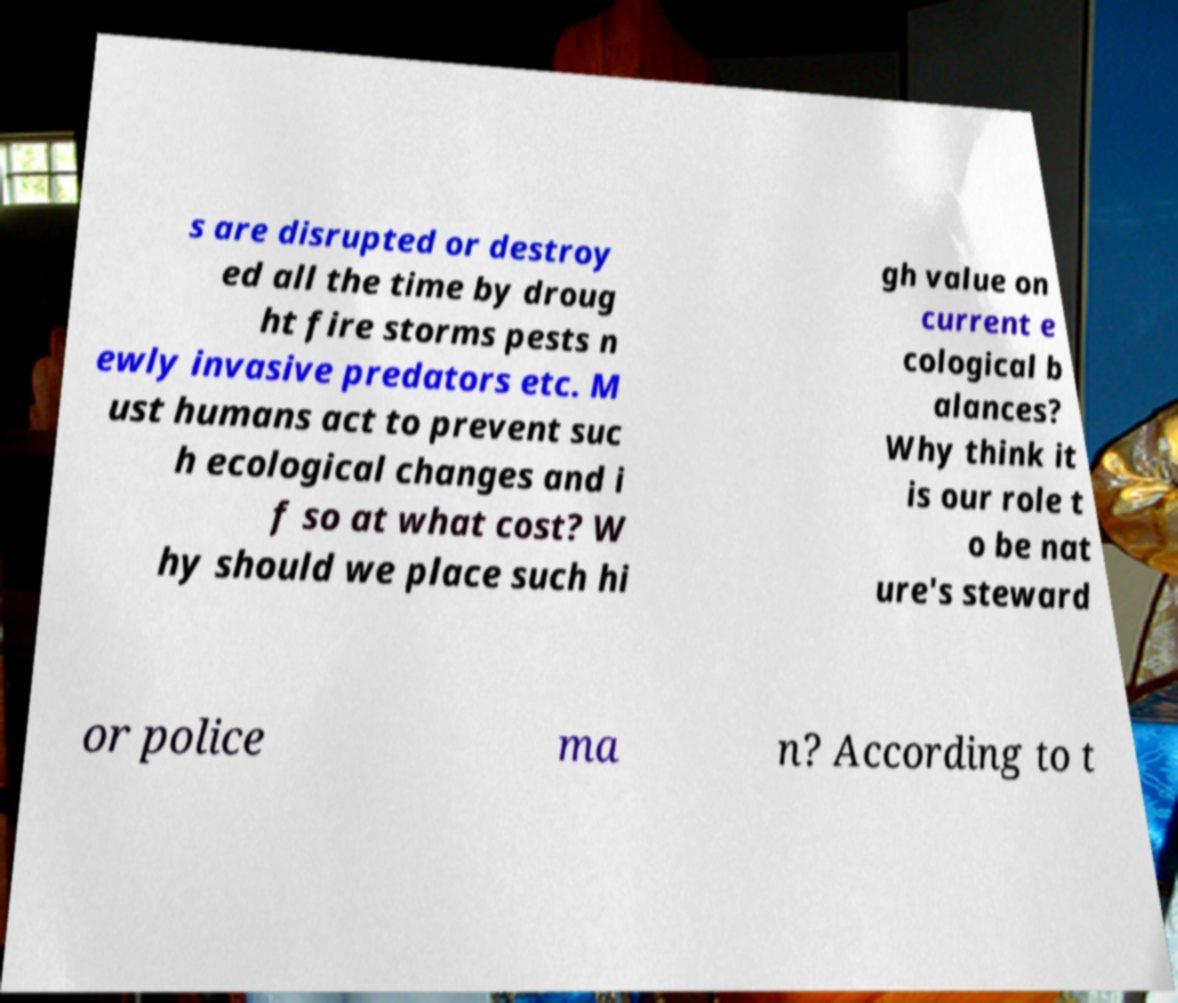Please read and relay the text visible in this image. What does it say? s are disrupted or destroy ed all the time by droug ht fire storms pests n ewly invasive predators etc. M ust humans act to prevent suc h ecological changes and i f so at what cost? W hy should we place such hi gh value on current e cological b alances? Why think it is our role t o be nat ure's steward or police ma n? According to t 